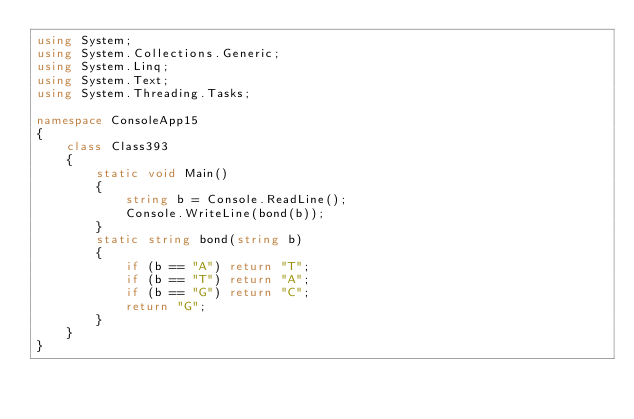Convert code to text. <code><loc_0><loc_0><loc_500><loc_500><_C#_>using System;
using System.Collections.Generic;
using System.Linq;
using System.Text;
using System.Threading.Tasks;

namespace ConsoleApp15
{
    class Class393
    {
        static void Main()
        {
            string b = Console.ReadLine();
            Console.WriteLine(bond(b));
        }
        static string bond(string b)
        {
            if (b == "A") return "T";
            if (b == "T") return "A";
            if (b == "G") return "C";
            return "G";
        }
    }
}
</code> 